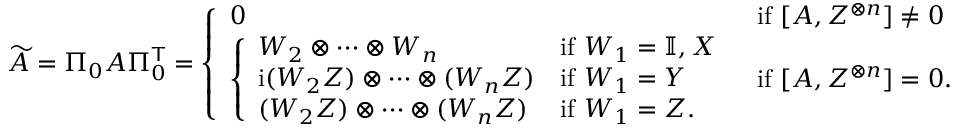<formula> <loc_0><loc_0><loc_500><loc_500>\widetilde { A } = \Pi _ { 0 } A \Pi _ { 0 } ^ { T } = \left \{ \begin{array} { l l } { 0 } & { i f [ A , Z ^ { \otimes n } ] \neq 0 } \\ { \left \{ \begin{array} { l l } { W _ { 2 } \otimes \cdots \otimes W _ { n } } & { i f W _ { 1 } = \mathbb { I } , X } \\ { i ( W _ { 2 } Z ) \otimes \cdots \otimes ( W _ { n } Z ) } & { i f W _ { 1 } = Y } \\ { ( W _ { 2 } Z ) \otimes \cdots \otimes ( W _ { n } Z ) } & { i f W _ { 1 } = Z . } \end{array} } & { i f [ A , Z ^ { \otimes n } ] = 0 . } \end{array}</formula> 